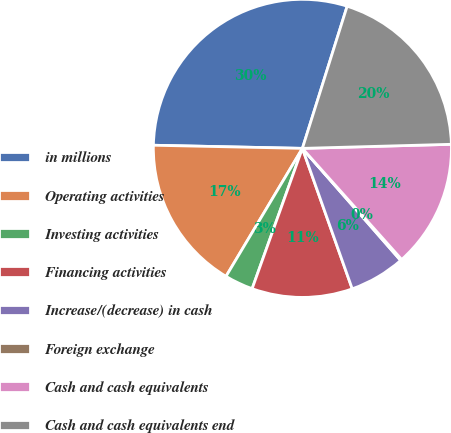Convert chart. <chart><loc_0><loc_0><loc_500><loc_500><pie_chart><fcel>in millions<fcel>Operating activities<fcel>Investing activities<fcel>Financing activities<fcel>Increase/(decrease) in cash<fcel>Foreign exchange<fcel>Cash and cash equivalents<fcel>Cash and cash equivalents end<nl><fcel>29.52%<fcel>16.77%<fcel>3.09%<fcel>10.9%<fcel>6.03%<fcel>0.15%<fcel>13.83%<fcel>19.71%<nl></chart> 